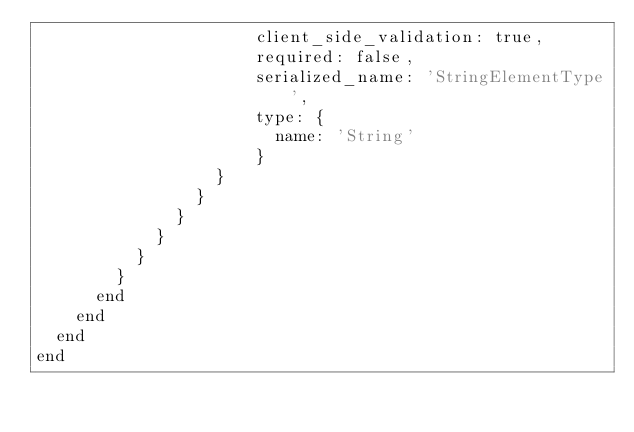<code> <loc_0><loc_0><loc_500><loc_500><_Ruby_>                      client_side_validation: true,
                      required: false,
                      serialized_name: 'StringElementType',
                      type: {
                        name: 'String'
                      }
                  }
                }
              }
            }
          }
        }
      end
    end
  end
end
</code> 